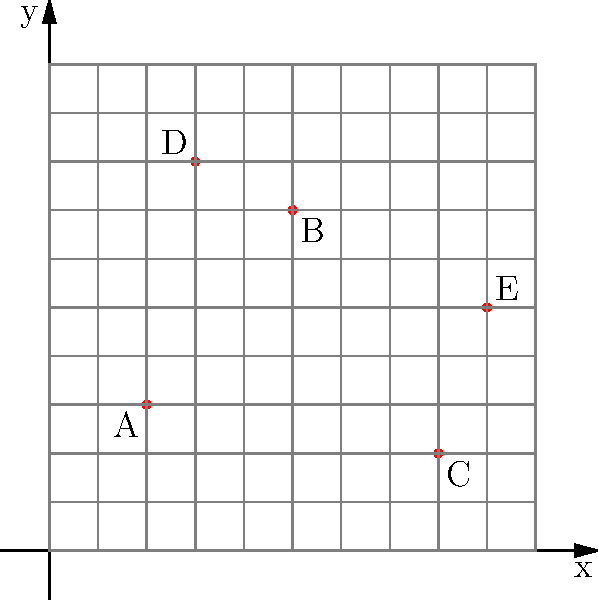The map above shows the locations of five local breastfeeding support centers (A, B, C, D, and E) in a city. Which center is located farthest from the origin (0,0), and what are its coordinates? To determine which center is farthest from the origin and its coordinates, we need to follow these steps:

1. Identify the coordinates of each center:
   A: (2,3)
   B: (5,7)
   C: (8,2)
   D: (3,8)
   E: (9,5)

2. Calculate the distance from each point to the origin (0,0) using the distance formula:
   $d = \sqrt{x^2 + y^2}$

3. For each center:
   A: $d_A = \sqrt{2^2 + 3^2} = \sqrt{4 + 9} = \sqrt{13} \approx 3.61$
   B: $d_B = \sqrt{5^2 + 7^2} = \sqrt{25 + 49} = \sqrt{74} \approx 8.60$
   C: $d_C = \sqrt{8^2 + 2^2} = \sqrt{64 + 4} = \sqrt{68} \approx 8.25$
   D: $d_D = \sqrt{3^2 + 8^2} = \sqrt{9 + 64} = \sqrt{73} \approx 8.54$
   E: $d_E = \sqrt{9^2 + 5^2} = \sqrt{81 + 25} = \sqrt{106} \approx 10.30$

4. Compare the distances:
   $d_E > d_B > d_D > d_C > d_A$

5. The center farthest from the origin is E, with coordinates (9,5).
Answer: E (9,5) 